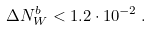<formula> <loc_0><loc_0><loc_500><loc_500>\Delta N _ { W } ^ { b } < 1 . 2 \cdot 1 0 ^ { - 2 } \, .</formula> 